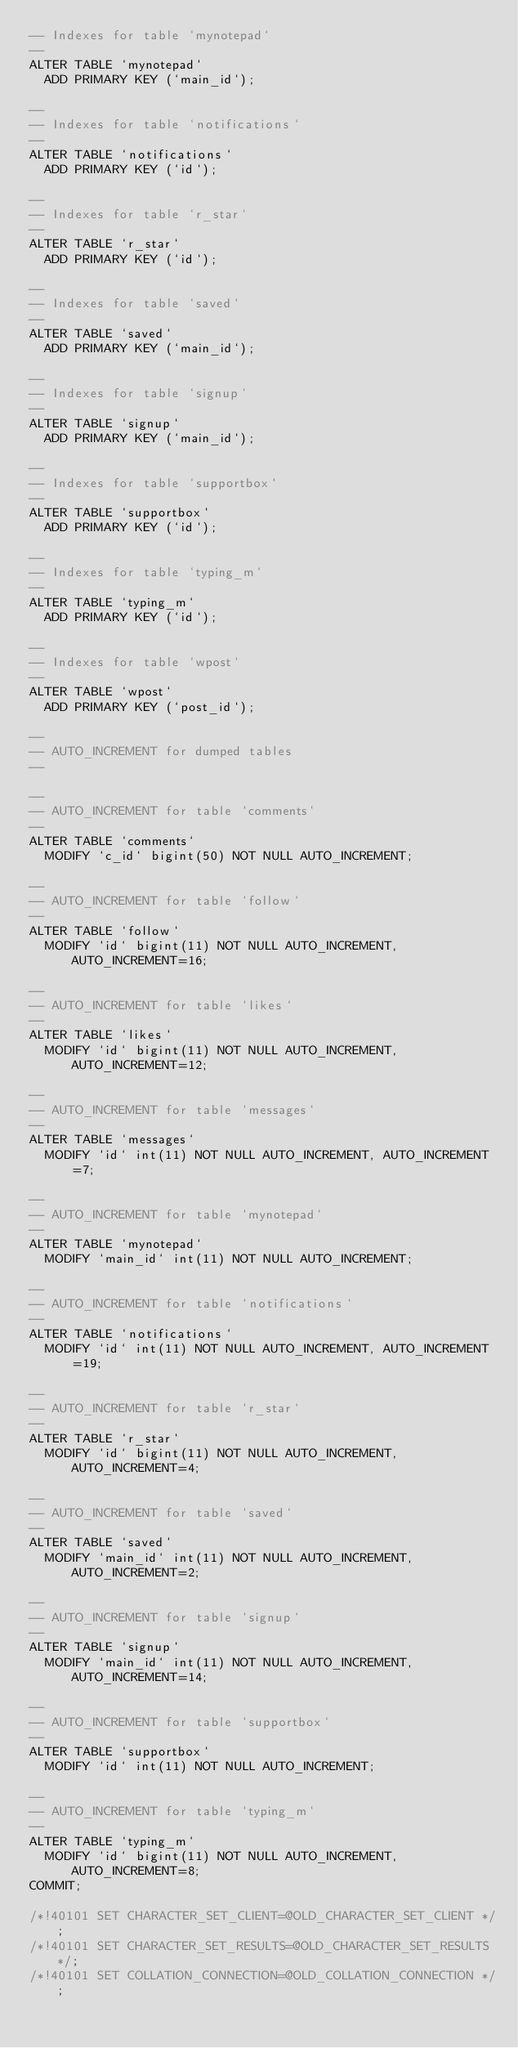<code> <loc_0><loc_0><loc_500><loc_500><_SQL_>-- Indexes for table `mynotepad`
--
ALTER TABLE `mynotepad`
  ADD PRIMARY KEY (`main_id`);

--
-- Indexes for table `notifications`
--
ALTER TABLE `notifications`
  ADD PRIMARY KEY (`id`);

--
-- Indexes for table `r_star`
--
ALTER TABLE `r_star`
  ADD PRIMARY KEY (`id`);

--
-- Indexes for table `saved`
--
ALTER TABLE `saved`
  ADD PRIMARY KEY (`main_id`);

--
-- Indexes for table `signup`
--
ALTER TABLE `signup`
  ADD PRIMARY KEY (`main_id`);

--
-- Indexes for table `supportbox`
--
ALTER TABLE `supportbox`
  ADD PRIMARY KEY (`id`);

--
-- Indexes for table `typing_m`
--
ALTER TABLE `typing_m`
  ADD PRIMARY KEY (`id`);

--
-- Indexes for table `wpost`
--
ALTER TABLE `wpost`
  ADD PRIMARY KEY (`post_id`);

--
-- AUTO_INCREMENT for dumped tables
--

--
-- AUTO_INCREMENT for table `comments`
--
ALTER TABLE `comments`
  MODIFY `c_id` bigint(50) NOT NULL AUTO_INCREMENT;

--
-- AUTO_INCREMENT for table `follow`
--
ALTER TABLE `follow`
  MODIFY `id` bigint(11) NOT NULL AUTO_INCREMENT, AUTO_INCREMENT=16;

--
-- AUTO_INCREMENT for table `likes`
--
ALTER TABLE `likes`
  MODIFY `id` bigint(11) NOT NULL AUTO_INCREMENT, AUTO_INCREMENT=12;

--
-- AUTO_INCREMENT for table `messages`
--
ALTER TABLE `messages`
  MODIFY `id` int(11) NOT NULL AUTO_INCREMENT, AUTO_INCREMENT=7;

--
-- AUTO_INCREMENT for table `mynotepad`
--
ALTER TABLE `mynotepad`
  MODIFY `main_id` int(11) NOT NULL AUTO_INCREMENT;

--
-- AUTO_INCREMENT for table `notifications`
--
ALTER TABLE `notifications`
  MODIFY `id` int(11) NOT NULL AUTO_INCREMENT, AUTO_INCREMENT=19;

--
-- AUTO_INCREMENT for table `r_star`
--
ALTER TABLE `r_star`
  MODIFY `id` bigint(11) NOT NULL AUTO_INCREMENT, AUTO_INCREMENT=4;

--
-- AUTO_INCREMENT for table `saved`
--
ALTER TABLE `saved`
  MODIFY `main_id` int(11) NOT NULL AUTO_INCREMENT, AUTO_INCREMENT=2;

--
-- AUTO_INCREMENT for table `signup`
--
ALTER TABLE `signup`
  MODIFY `main_id` int(11) NOT NULL AUTO_INCREMENT, AUTO_INCREMENT=14;

--
-- AUTO_INCREMENT for table `supportbox`
--
ALTER TABLE `supportbox`
  MODIFY `id` int(11) NOT NULL AUTO_INCREMENT;

--
-- AUTO_INCREMENT for table `typing_m`
--
ALTER TABLE `typing_m`
  MODIFY `id` bigint(11) NOT NULL AUTO_INCREMENT, AUTO_INCREMENT=8;
COMMIT;

/*!40101 SET CHARACTER_SET_CLIENT=@OLD_CHARACTER_SET_CLIENT */;
/*!40101 SET CHARACTER_SET_RESULTS=@OLD_CHARACTER_SET_RESULTS */;
/*!40101 SET COLLATION_CONNECTION=@OLD_COLLATION_CONNECTION */;
</code> 